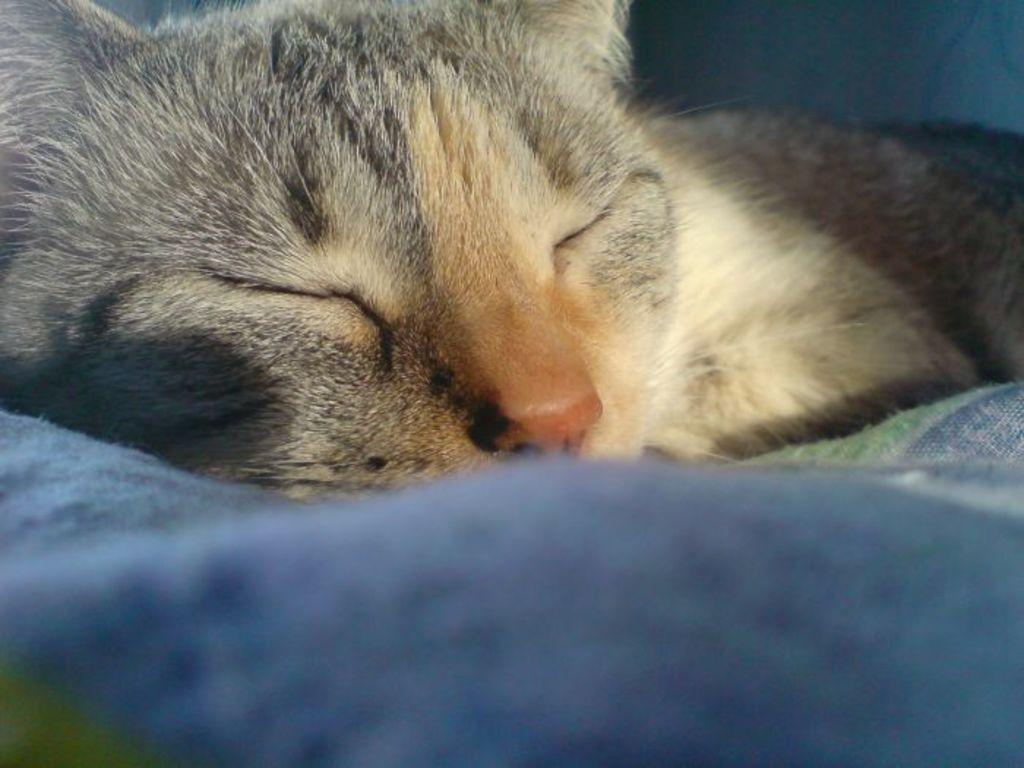What animal can be seen in the picture? There is a cat in the picture. What is the cat doing in the picture? The cat is sleeping. What object is visible at the bottom portion of the picture? There is a blanket visible at the bottom portion of the picture. Reasoning: Let' Let's think step by step in order to produce the conversation. We start by identifying the main subject in the image, which is the cat. Then, we describe the cat's action, which is sleeping. Finally, we mention the blanket that is visible at the bottom of the picture. Each question is designed to elicit a specific detail about the image that is known from the provided facts. Absurd Question/Answer: What type of credit card is the cat holding in the picture? There is no credit card present in the image; the cat is sleeping on a blanket. 